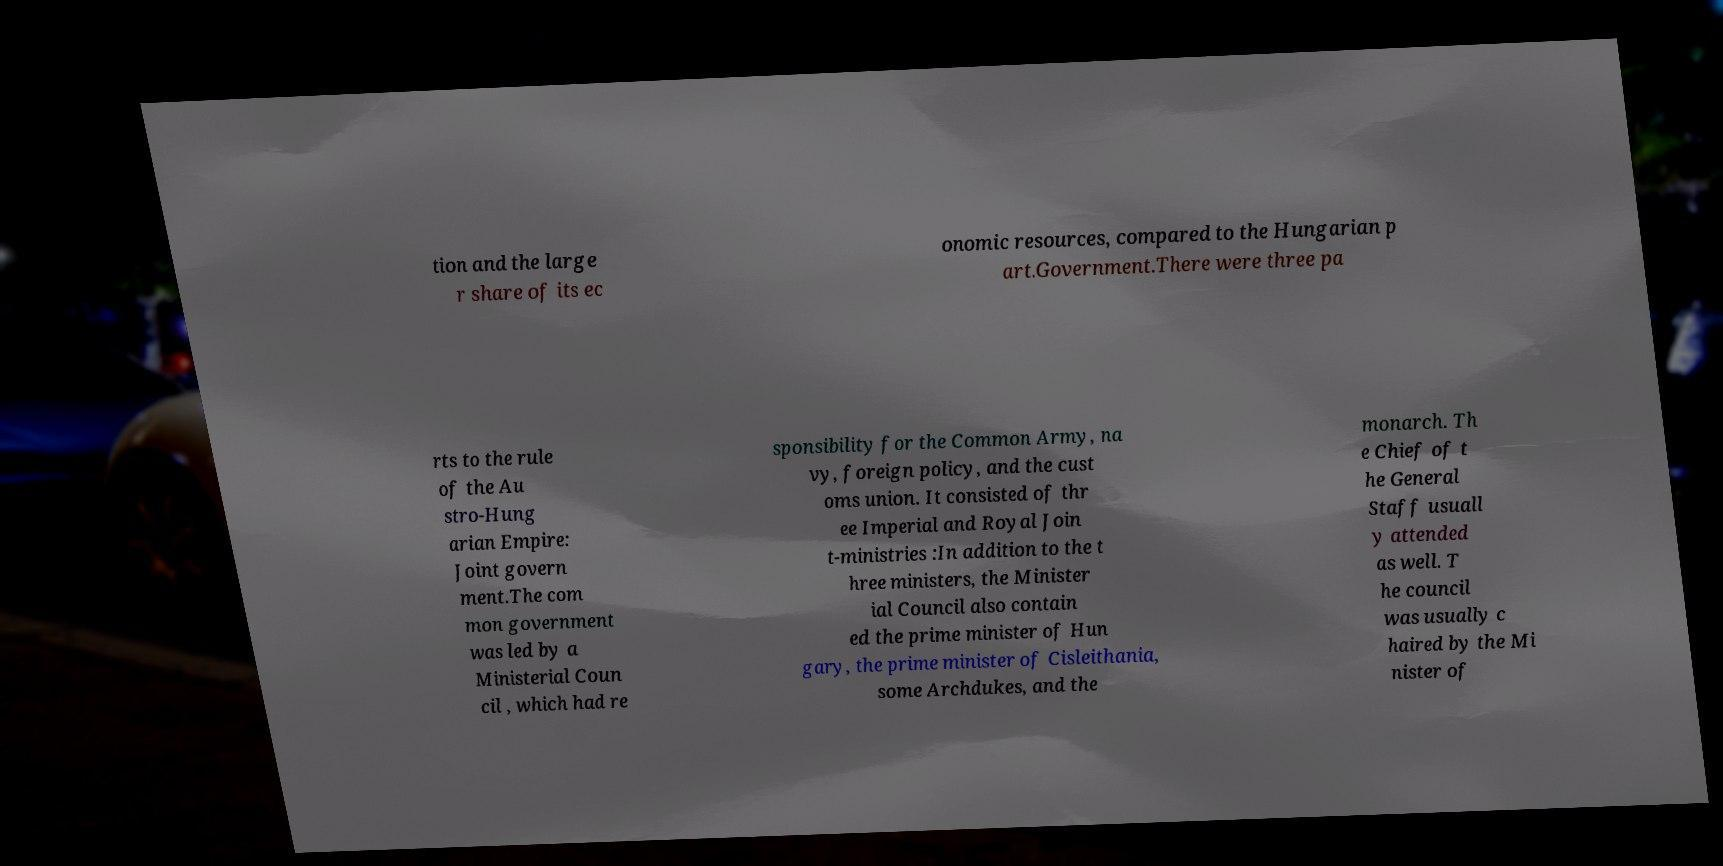Please read and relay the text visible in this image. What does it say? tion and the large r share of its ec onomic resources, compared to the Hungarian p art.Government.There were three pa rts to the rule of the Au stro-Hung arian Empire: Joint govern ment.The com mon government was led by a Ministerial Coun cil , which had re sponsibility for the Common Army, na vy, foreign policy, and the cust oms union. It consisted of thr ee Imperial and Royal Join t-ministries :In addition to the t hree ministers, the Minister ial Council also contain ed the prime minister of Hun gary, the prime minister of Cisleithania, some Archdukes, and the monarch. Th e Chief of t he General Staff usuall y attended as well. T he council was usually c haired by the Mi nister of 